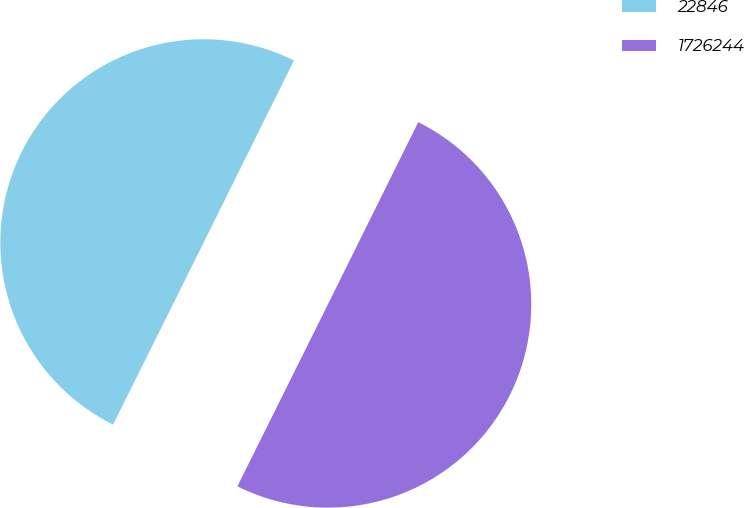Convert chart. <chart><loc_0><loc_0><loc_500><loc_500><pie_chart><fcel>22846<fcel>1726244<nl><fcel>49.98%<fcel>50.02%<nl></chart> 